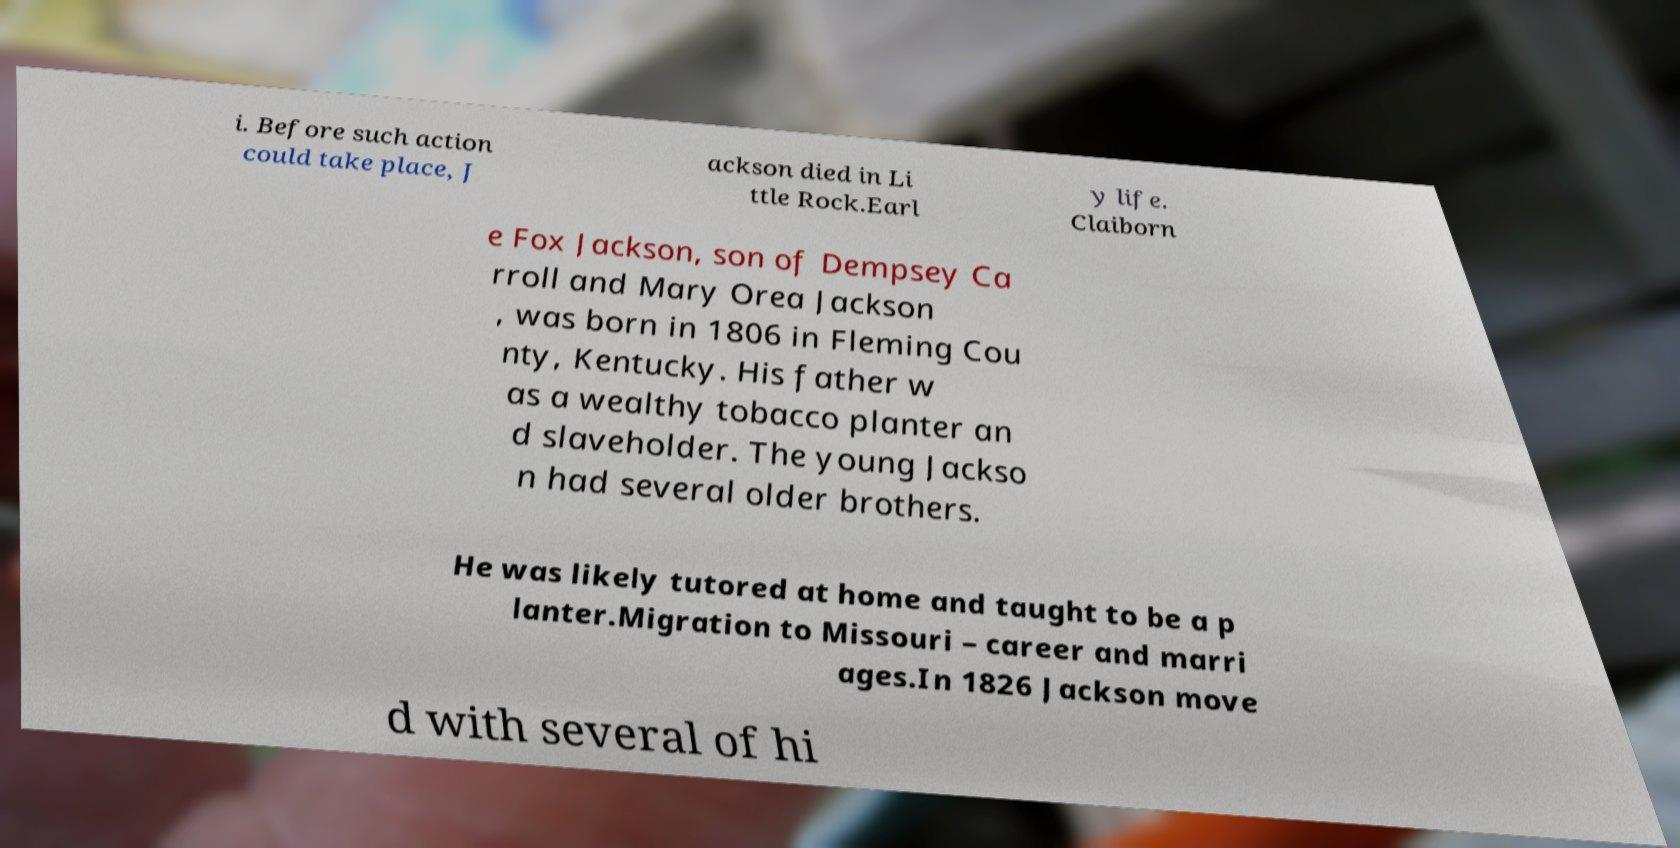I need the written content from this picture converted into text. Can you do that? i. Before such action could take place, J ackson died in Li ttle Rock.Earl y life. Claiborn e Fox Jackson, son of Dempsey Ca rroll and Mary Orea Jackson , was born in 1806 in Fleming Cou nty, Kentucky. His father w as a wealthy tobacco planter an d slaveholder. The young Jackso n had several older brothers. He was likely tutored at home and taught to be a p lanter.Migration to Missouri – career and marri ages.In 1826 Jackson move d with several of hi 